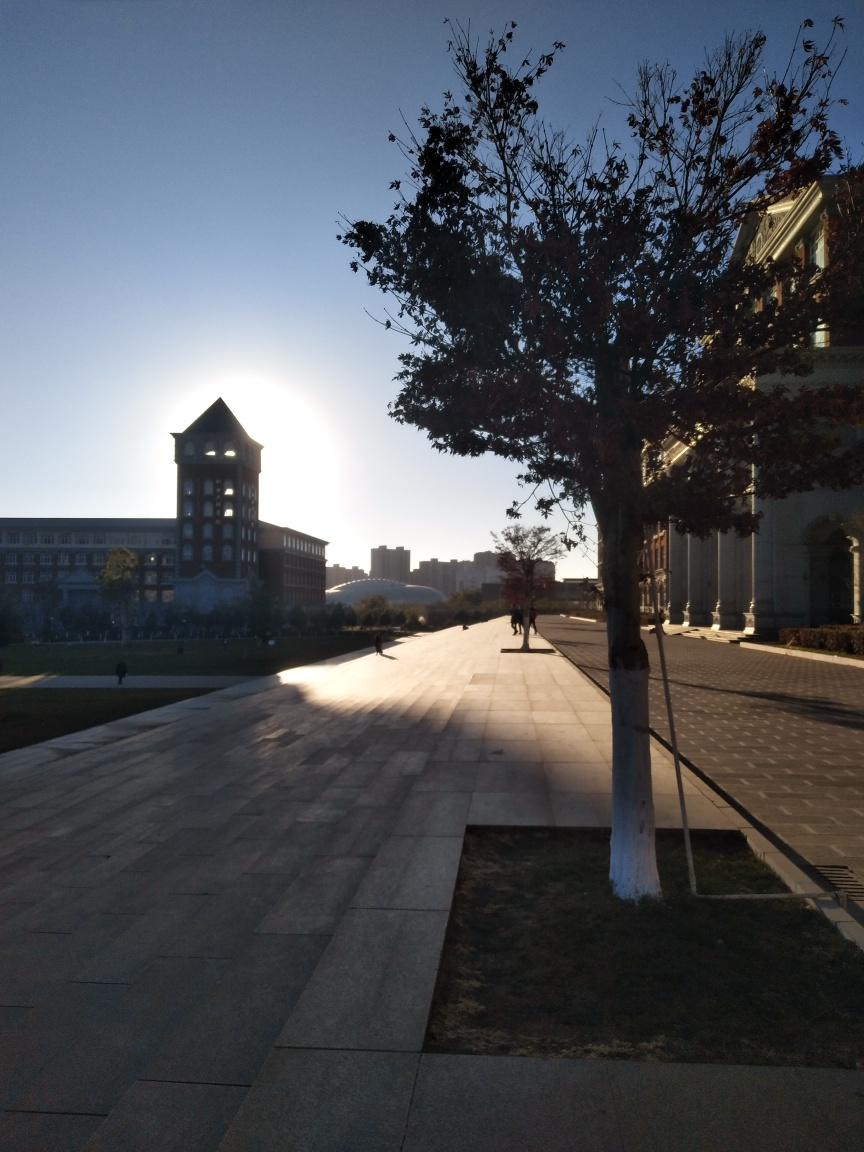Can you describe the architecture featured in this image? The architecture in the image presents a modern style building with large windows and a tower structure. The building has a symmetrical facade and uses materials that reflect sunlight prominently. 